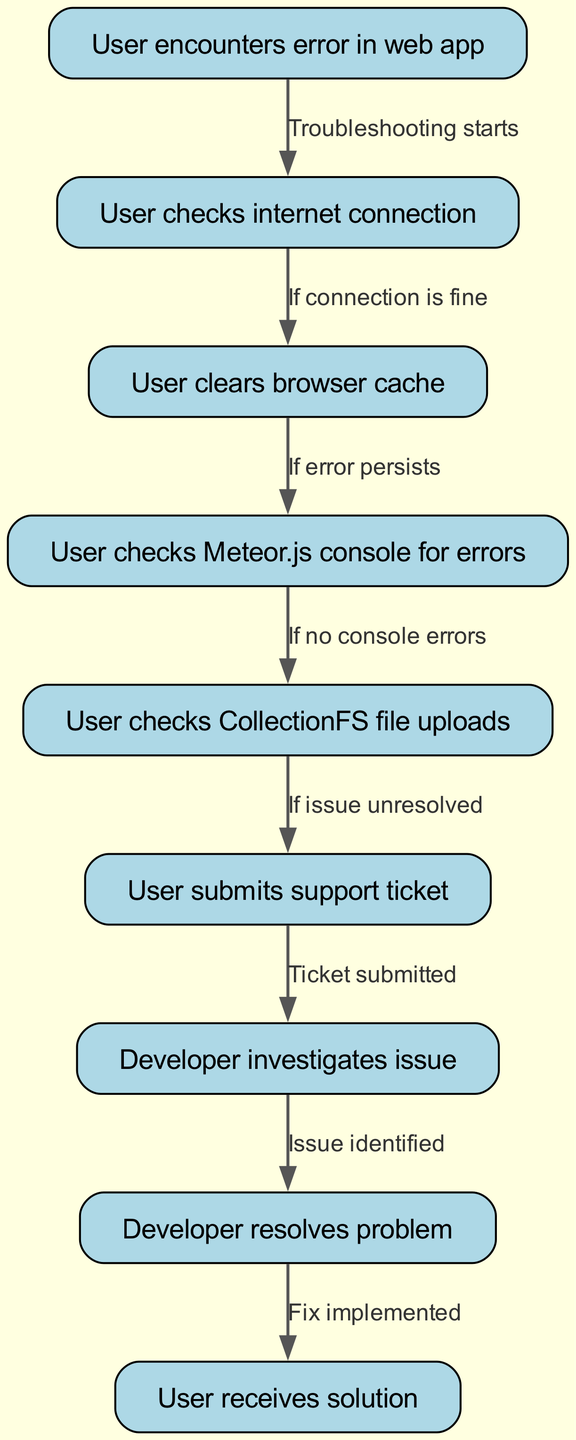What does the first node represent? The first node is labeled "User encounters error in web app," indicating the starting point of the pathway where the user experiences an issue in the web application.
Answer: User encounters error in web app How many total nodes are in the diagram? By counting the listed nodes, I find there are 9 unique nodes that describe different steps in the clinical pathway.
Answer: 9 What is the label of the last node? The last node is labeled "User receives solution," which signifies the endpoint of the user journey once the issue has been addressed.
Answer: User receives solution What action follows "User checks internet connection"? The action that follows is "User clears browser cache," indicating the next troubleshooting step if the internet connection is stable.
Answer: User clears browser cache What happens if there are no console errors after checking the Meteor.js console? If there are no console errors, the pathway directs to "User checks CollectionFS file uploads," suggesting the next area to investigate for potential issues.
Answer: User checks CollectionFS file uploads What is the relationship between submitting a support ticket and issue investigation? The relationship is that after the user submits a support ticket, the developer investigates the issue, indicating a progression from reporting to investigation.
Answer: Developer investigates issue If a user experiences an issue that remains unresolved, what should they do next? If the issue is unresolved, the user should submit a support ticket as the next step in the troubleshooting process.
Answer: Submit support ticket How many edges are in the diagram? By counting the connections (edges) represented in the diagram, there are a total of 8 edges that link the various nodes together.
Answer: 8 What label is given to the connection between "Developer investigates issue" and "Developer resolves problem"? The connection is labeled "Issue identified," indicating that the developer first identifies the issue before resolving it.
Answer: Issue identified 